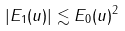<formula> <loc_0><loc_0><loc_500><loc_500>| E _ { 1 } ( u ) | \lesssim E _ { 0 } ( u ) ^ { 2 }</formula> 